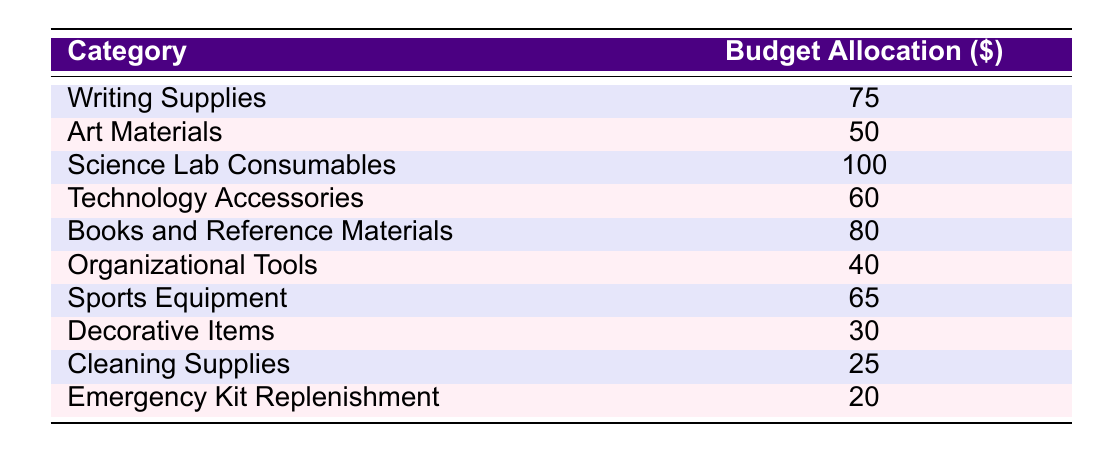What is the budget allocation for Art Materials? From the table, we can directly locate the row that corresponds to Art Materials, which shows a budget allocation of 50 dollars.
Answer: 50 Which category has the highest budget allocation? Looking through the table, the category with the highest budget allocation is Science Lab Consumables at 100 dollars.
Answer: Science Lab Consumables What is the total budget allocated for Writing Supplies, Technology Accessories, and Sports Equipment? We first identify the individual allocations: Writing Supplies is 75 dollars, Technology Accessories is 60 dollars, and Sports Equipment is 65 dollars. The total is calculated as 75 + 60 + 65 = 200 dollars.
Answer: 200 Is the budget allocation for Cleaning Supplies greater than for Decorative Items? The budget for Cleaning Supplies is 25 dollars, while Decorative Items is 30 dollars. Since 25 is not greater than 30, the answer is no.
Answer: No What is the average budget allocation for all categories? To find the average, we sum all the budget allocations: 75 + 50 + 100 + 60 + 80 + 40 + 65 + 30 + 25 + 20 = 570 dollars. There are 10 categories, so we divide the total by 10, resulting in an average of 570 / 10 = 57 dollars.
Answer: 57 How much more budget is allocated to Science Lab Consumables compared to Cleaning Supplies? Science Lab Consumables has a budget of 100 dollars, and Cleaning Supplies has a budget of 25 dollars. The difference is calculated as 100 - 25 = 75 dollars.
Answer: 75 Is the budget for Organizational Tools equal to the budget for Emergency Kit Replenishment? The budget for Organizational Tools is 40 dollars and for Emergency Kit Replenishment is 20 dollars. Since 40 is not equal to 20, the statement is false.
Answer: No What is the combined budget for all types of Supplies except for Art Materials and Cleaning Supplies? We first sum the remaining categories: Writing Supplies (75) + Science Lab Consumables (100) + Technology Accessories (60) + Books and Reference Materials (80) + Organizational Tools (40) + Sports Equipment (65) + Decorative Items (30) + Emergency Kit Replenishment (20). This equals 75 + 100 + 60 + 80 + 40 + 65 + 30 + 20 = 470 dollars.
Answer: 470 What percentage of the total budget allocation is allocated to Books and Reference Materials? First, we determine the total budget is 570 dollars. Books and Reference Materials has a budget of 80 dollars. The percentage is calculated as (80 / 570) * 100 ≈ 14.04%.
Answer: Approximately 14.04% 